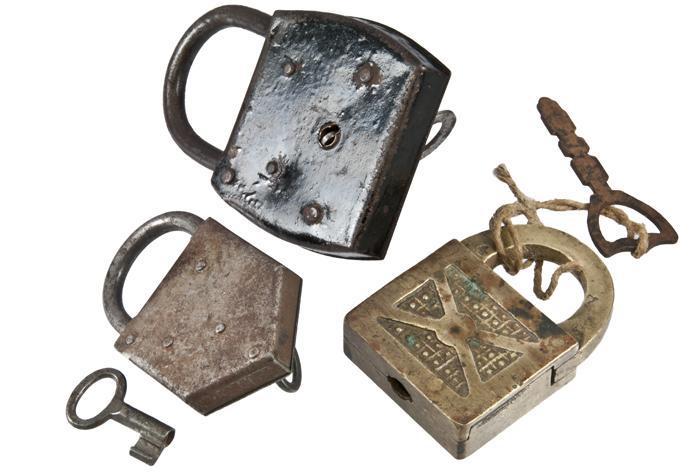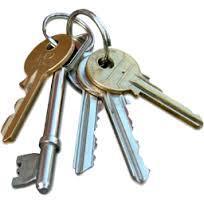The first image is the image on the left, the second image is the image on the right. Assess this claim about the two images: "An image shows a lock decorated with a human-like figure on its front and with a keyring attached.". Correct or not? Answer yes or no. No. The first image is the image on the left, the second image is the image on the right. Assess this claim about the two images: "In one of the images there is a lock with an image carved on the front and two keys attached to it.". Correct or not? Answer yes or no. No. 